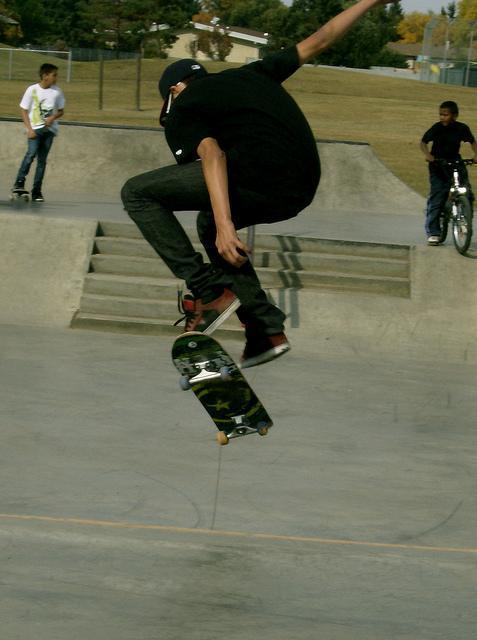How many steps are there?
Give a very brief answer. 6. How many people are in the photo?
Give a very brief answer. 3. 